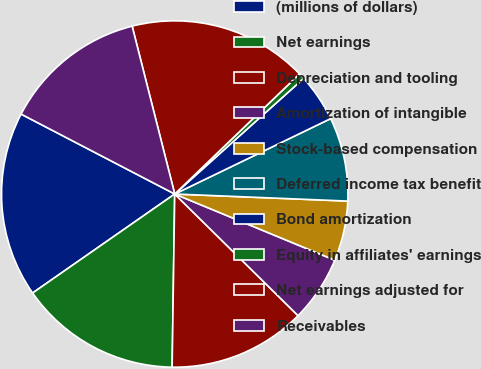Convert chart. <chart><loc_0><loc_0><loc_500><loc_500><pie_chart><fcel>(millions of dollars)<fcel>Net earnings<fcel>Depreciation and tooling<fcel>Amortization of intangible<fcel>Stock-based compensation<fcel>Deferred income tax benefit<fcel>Bond amortization<fcel>Equity in affiliates' earnings<fcel>Net earnings adjusted for<fcel>Receivables<nl><fcel>17.32%<fcel>15.08%<fcel>12.85%<fcel>6.15%<fcel>5.59%<fcel>7.82%<fcel>4.47%<fcel>0.56%<fcel>16.76%<fcel>13.41%<nl></chart> 